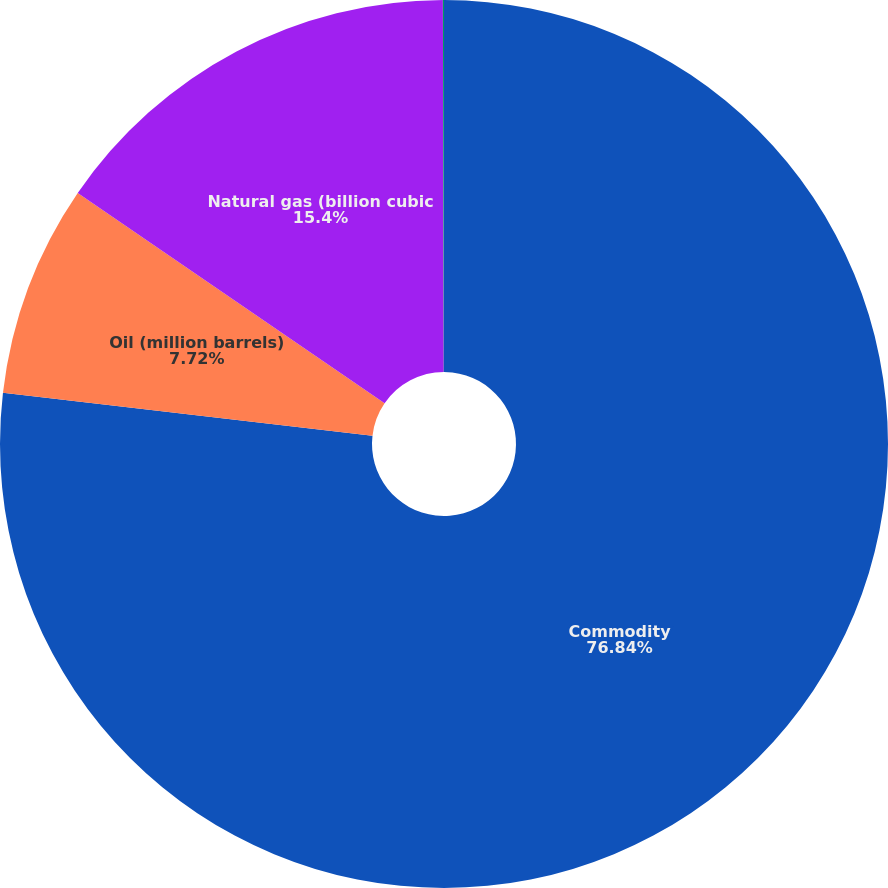Convert chart. <chart><loc_0><loc_0><loc_500><loc_500><pie_chart><fcel>Commodity<fcel>Oil (million barrels)<fcel>Natural gas (billion cubic<fcel>Precious metals (million troy<nl><fcel>76.84%<fcel>7.72%<fcel>15.4%<fcel>0.04%<nl></chart> 